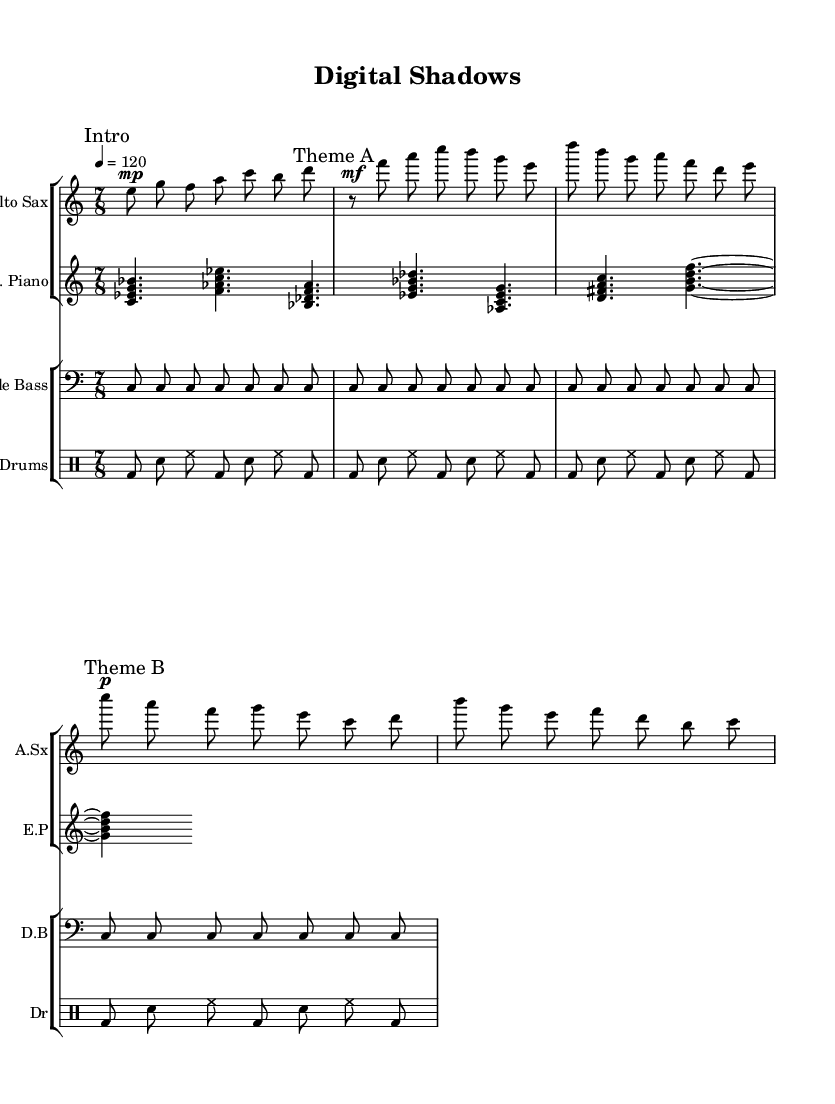What is the time signature of this music? The time signature is 7/8, which can be found in the global settings at the beginning of the code. It indicates there are seven beats in each measure with an eighth note receiving one beat.
Answer: 7/8 What is the tempo of this piece? The tempo is marked as quarter note equals 120 beats per minute, as specified in the tempo setting within the global section of the code.
Answer: 120 How many distinct themes are present in the piece? There are two themes, indicated as Theme A and Theme B in the saxophone part. Each theme is labeled with a corresponding mark in the sheet music.
Answer: 2 What instrument plays the bass part? The bass part is played by the Double Bass, as indicated at the beginning of the double bass section in the code.
Answer: Double Bass How many measures are in the drum pattern? There are 8 measures in the drum pattern, as the pattern is repeated for four lines and each line contains two measures. This totals to 8 measures in the drum staff.
Answer: 8 Which instrument has a dynamic marking of "mp"? The alto saxophone part has a dynamic marking of "mp" (mezzo-piano) at the start of the intro section, which is specified in the score for the alto saxophone.
Answer: Alto Sax What is the root note of the first chord played by the electric piano? The root note of the first chord played by the electric piano is C, as seen in the first chord notation of the electric piano part in the code.
Answer: C 